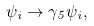<formula> <loc_0><loc_0><loc_500><loc_500>\psi _ { i } \rightarrow \gamma _ { 5 } \psi _ { i } ,</formula> 